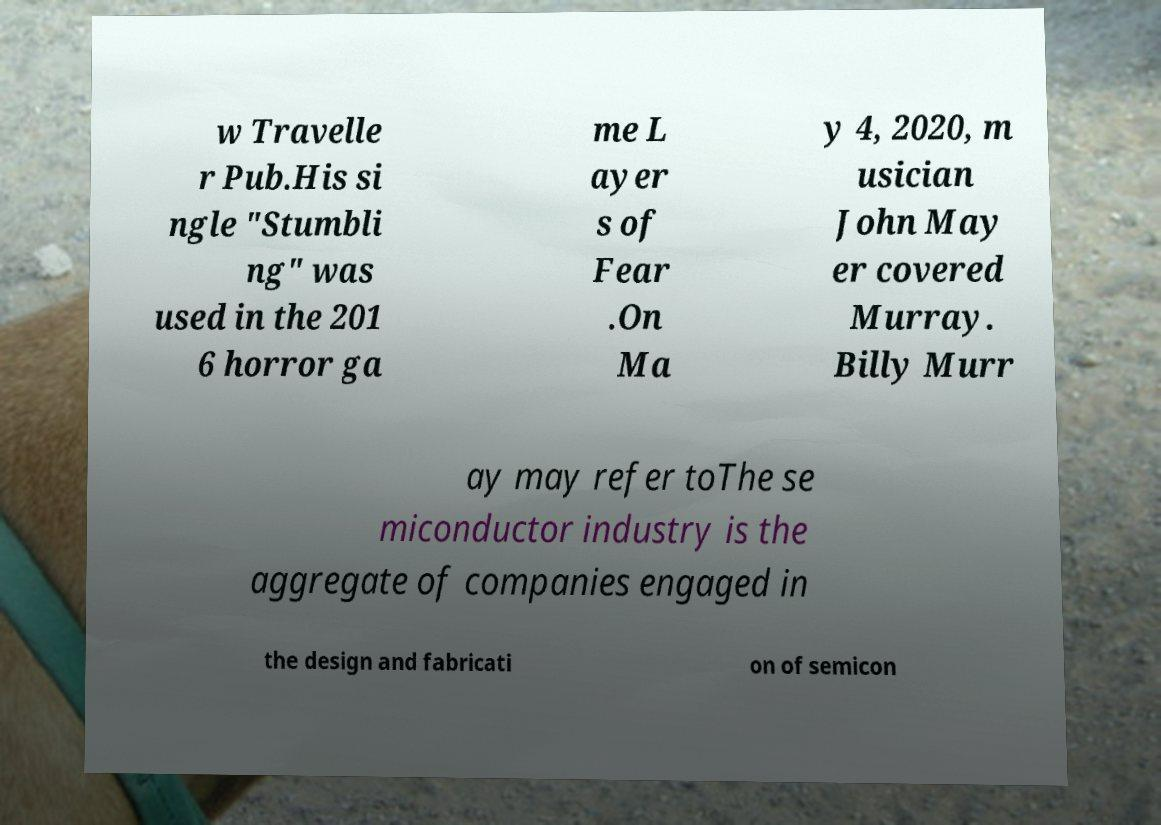Please read and relay the text visible in this image. What does it say? w Travelle r Pub.His si ngle "Stumbli ng" was used in the 201 6 horror ga me L ayer s of Fear .On Ma y 4, 2020, m usician John May er covered Murray. Billy Murr ay may refer toThe se miconductor industry is the aggregate of companies engaged in the design and fabricati on of semicon 